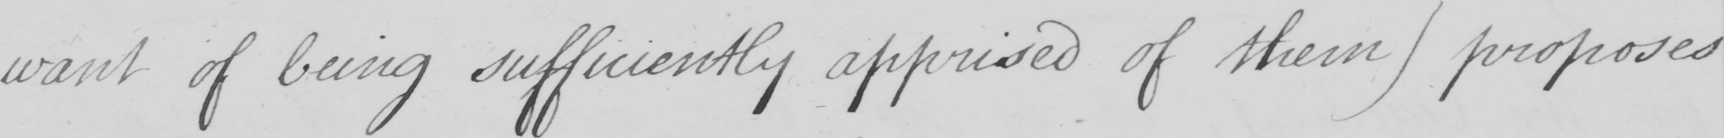Can you read and transcribe this handwriting? want of being sufficiently apprised of these )  proposes 